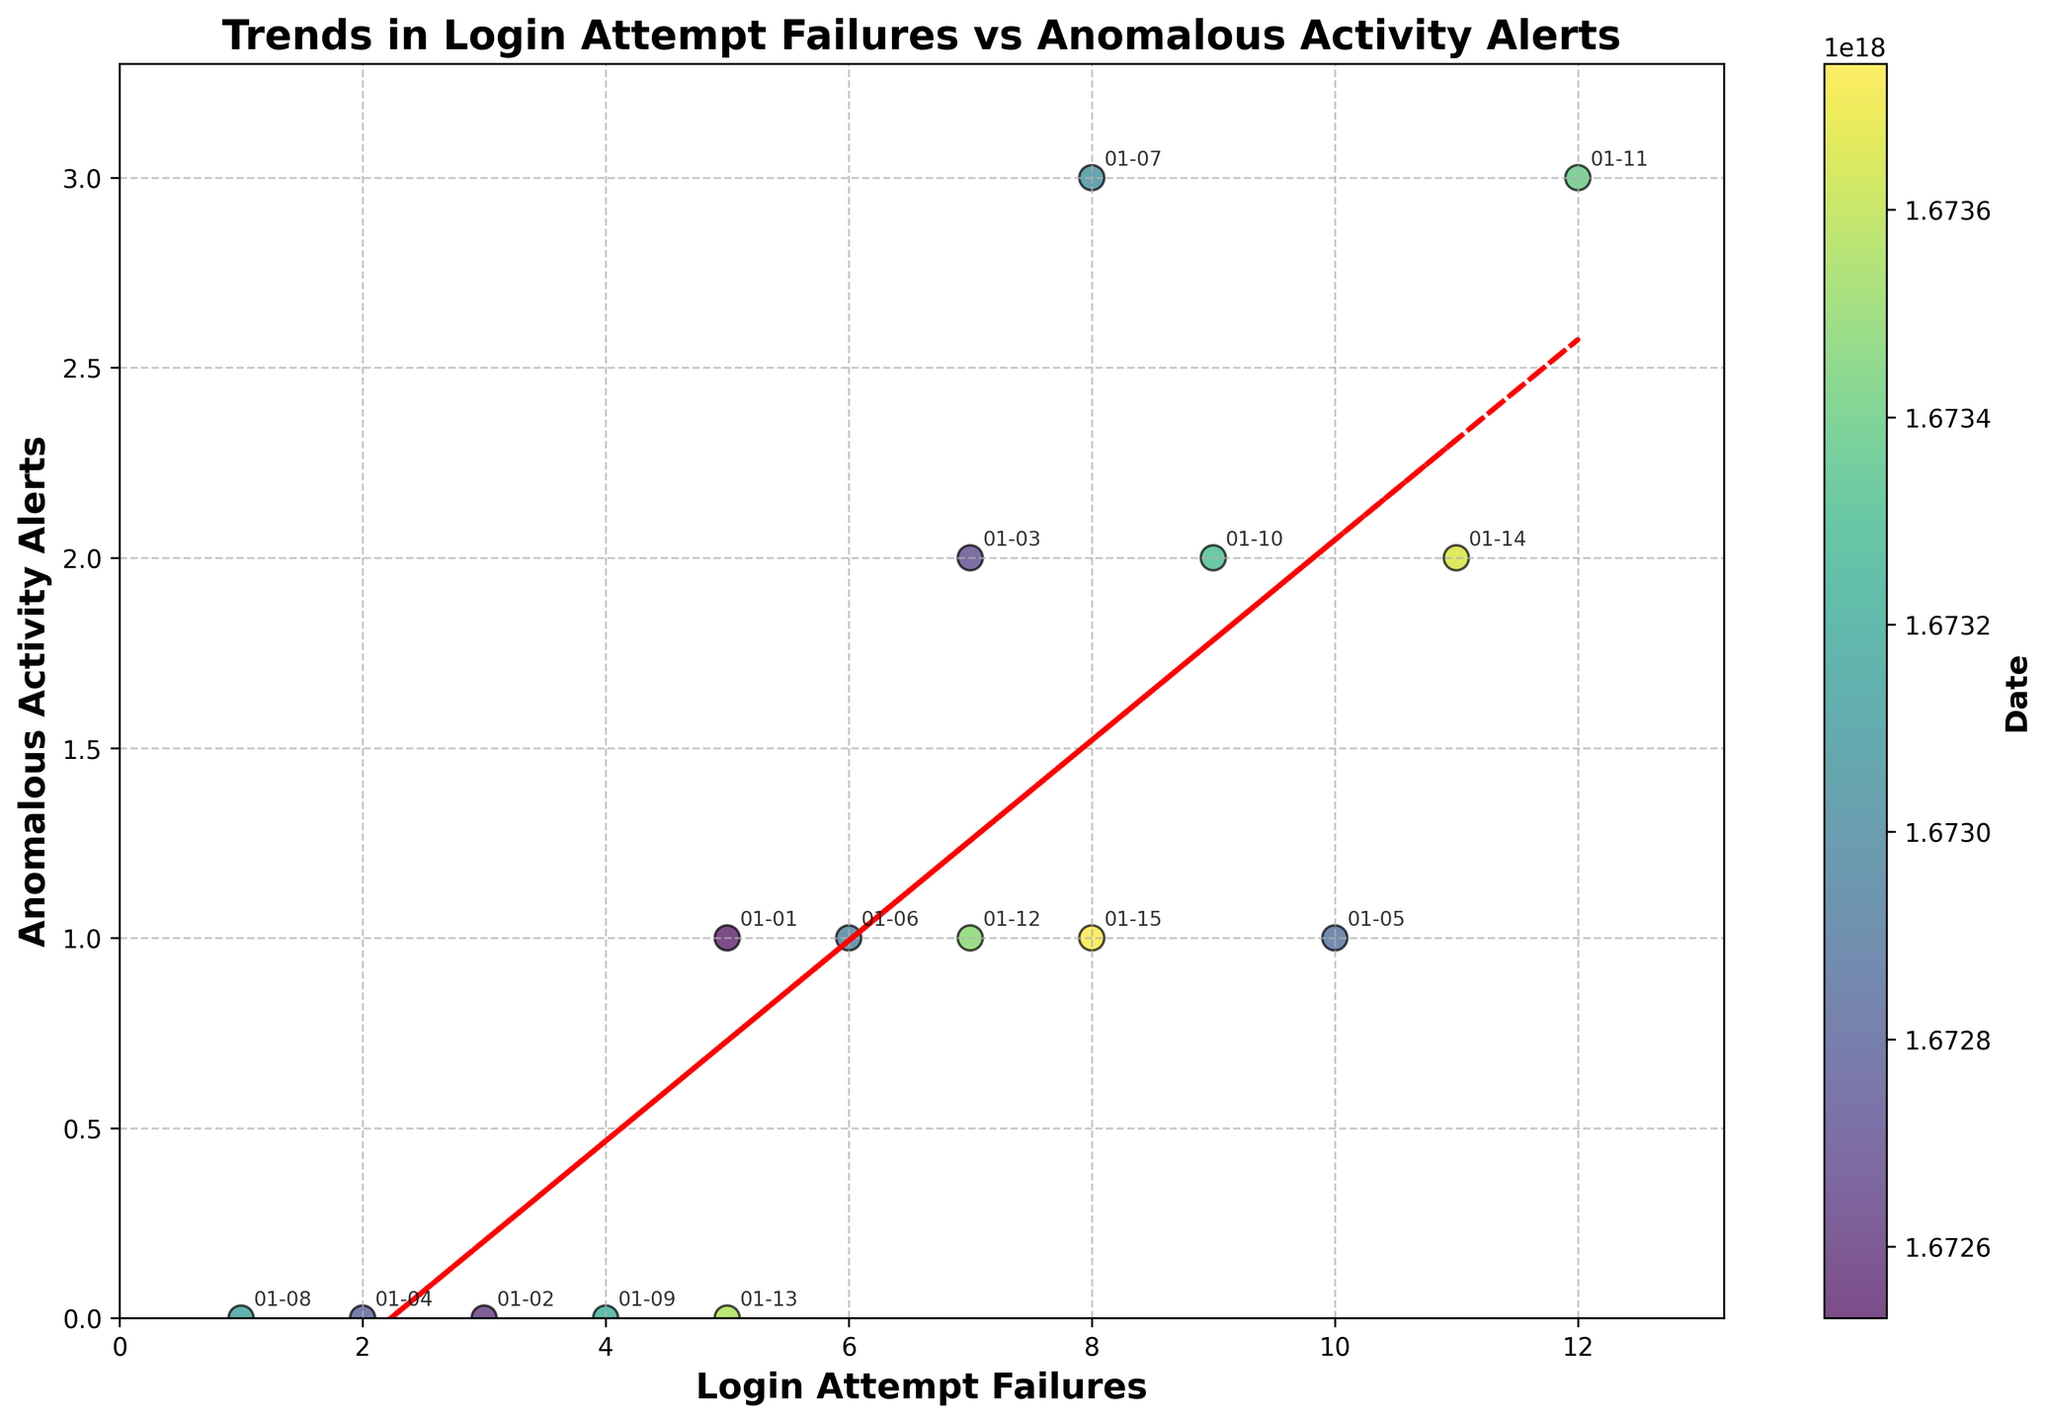What's the title of the scatter plot? The title is prominently displayed at the top of the figure. It reads "Trends in Login Attempt Failures vs Anomalous Activity Alerts".
Answer: Trends in Login Attempt Failures vs Anomalous Activity Alerts What are the labels of the x-axis and y-axis? The labels are directly named under each axis of the plot. The x-axis is labeled "Login Attempt Failures" and the y-axis is labeled "Anomalous Activity Alerts".
Answer: Login Attempt Failures and Anomalous Activity Alerts How does the trend line behave as login attempt failures increase? The trend line, which is red and dashed, generally increases as the number of login attempt failures increases, indicating a positive relationship between login attempt failures and anomalous activity alerts.
Answer: Increases How many anomalous activity alerts are observed with the maximum number of login attempt failures? By looking at the scatter plot, the point with the highest x-value (login attempt failures) corresponds to 12 login attempt failures and a y-value (anomalous activity alerts) of 3.
Answer: 3 Which date shows the highest number of login attempt failures? The date at the point with the highest x-value (12 login attempt failures) is annotated on the plot. It states 2023-01-11.
Answer: 2023-01-11 What is the color of the points used to denote login attempt failures and anomalous activity alerts? The points are represented using a color gradient ranging from yellow to green, with colors mapped to specific dates.
Answer: Yellow to green gradient Is there a consistent increase in anomalous activity alerts as login attempt failures increase? Although there is a positive trend line, the data points show variability, meaning that the increase in anomalous activity alerts is not consistent for each increase in login attempt failures. There are fluctuations.
Answer: No Compare the number of anomalous activity alerts on 2023-01-03 and 2023-01-08. Which date had more? By observing the annotated points, 2023-01-03 shows 2 anomalous activity alerts while 2023-01-08 shows 0. Therefore, 2023-01-03 had more alerts.
Answer: 2023-01-03 What does the color bar represent in the scatter plot? The color bar labeled "Date" represents the mapping of dates to the color gradient used for the scatter plot points, correlating with the timeline in January 2023.
Answer: Date Are there any dates with the same number of login attempt failures? If so, which ones? Checking the data points closely, the dates 2023-01-01 and 2023-01-13 both have 5 login attempt failures.
Answer: 2023-01-01 and 2023-01-13 